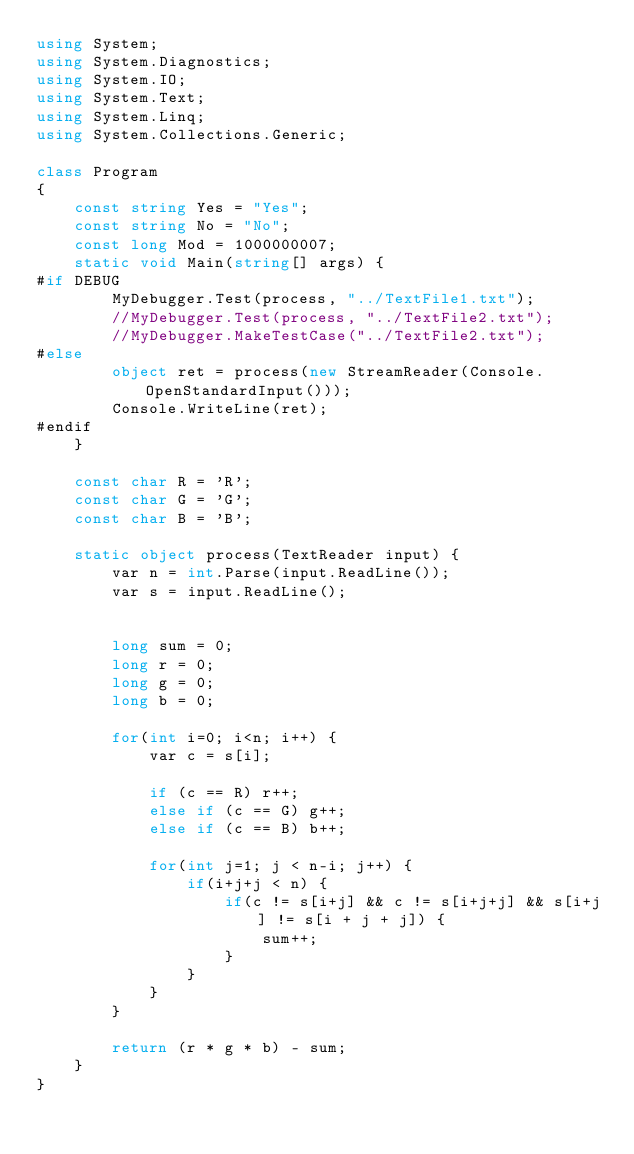<code> <loc_0><loc_0><loc_500><loc_500><_C#_>using System;
using System.Diagnostics;
using System.IO;
using System.Text;
using System.Linq;
using System.Collections.Generic;

class Program
{
    const string Yes = "Yes";
    const string No = "No";
    const long Mod = 1000000007;
    static void Main(string[] args) {
#if DEBUG
        MyDebugger.Test(process, "../TextFile1.txt");
        //MyDebugger.Test(process, "../TextFile2.txt");
        //MyDebugger.MakeTestCase("../TextFile2.txt");
#else
        object ret = process(new StreamReader(Console.OpenStandardInput()));
        Console.WriteLine(ret);
#endif
    }

    const char R = 'R';
    const char G = 'G';
    const char B = 'B';

    static object process(TextReader input) {
        var n = int.Parse(input.ReadLine());
        var s = input.ReadLine();


        long sum = 0;
        long r = 0;
        long g = 0;
        long b = 0;

        for(int i=0; i<n; i++) {
            var c = s[i];

            if (c == R) r++;
            else if (c == G) g++;
            else if (c == B) b++;

            for(int j=1; j < n-i; j++) {
                if(i+j+j < n) {
                    if(c != s[i+j] && c != s[i+j+j] && s[i+j] != s[i + j + j]) {
                        sum++;
                    }
                }
            }
        }

        return (r * g * b) - sum;
    }
}
</code> 